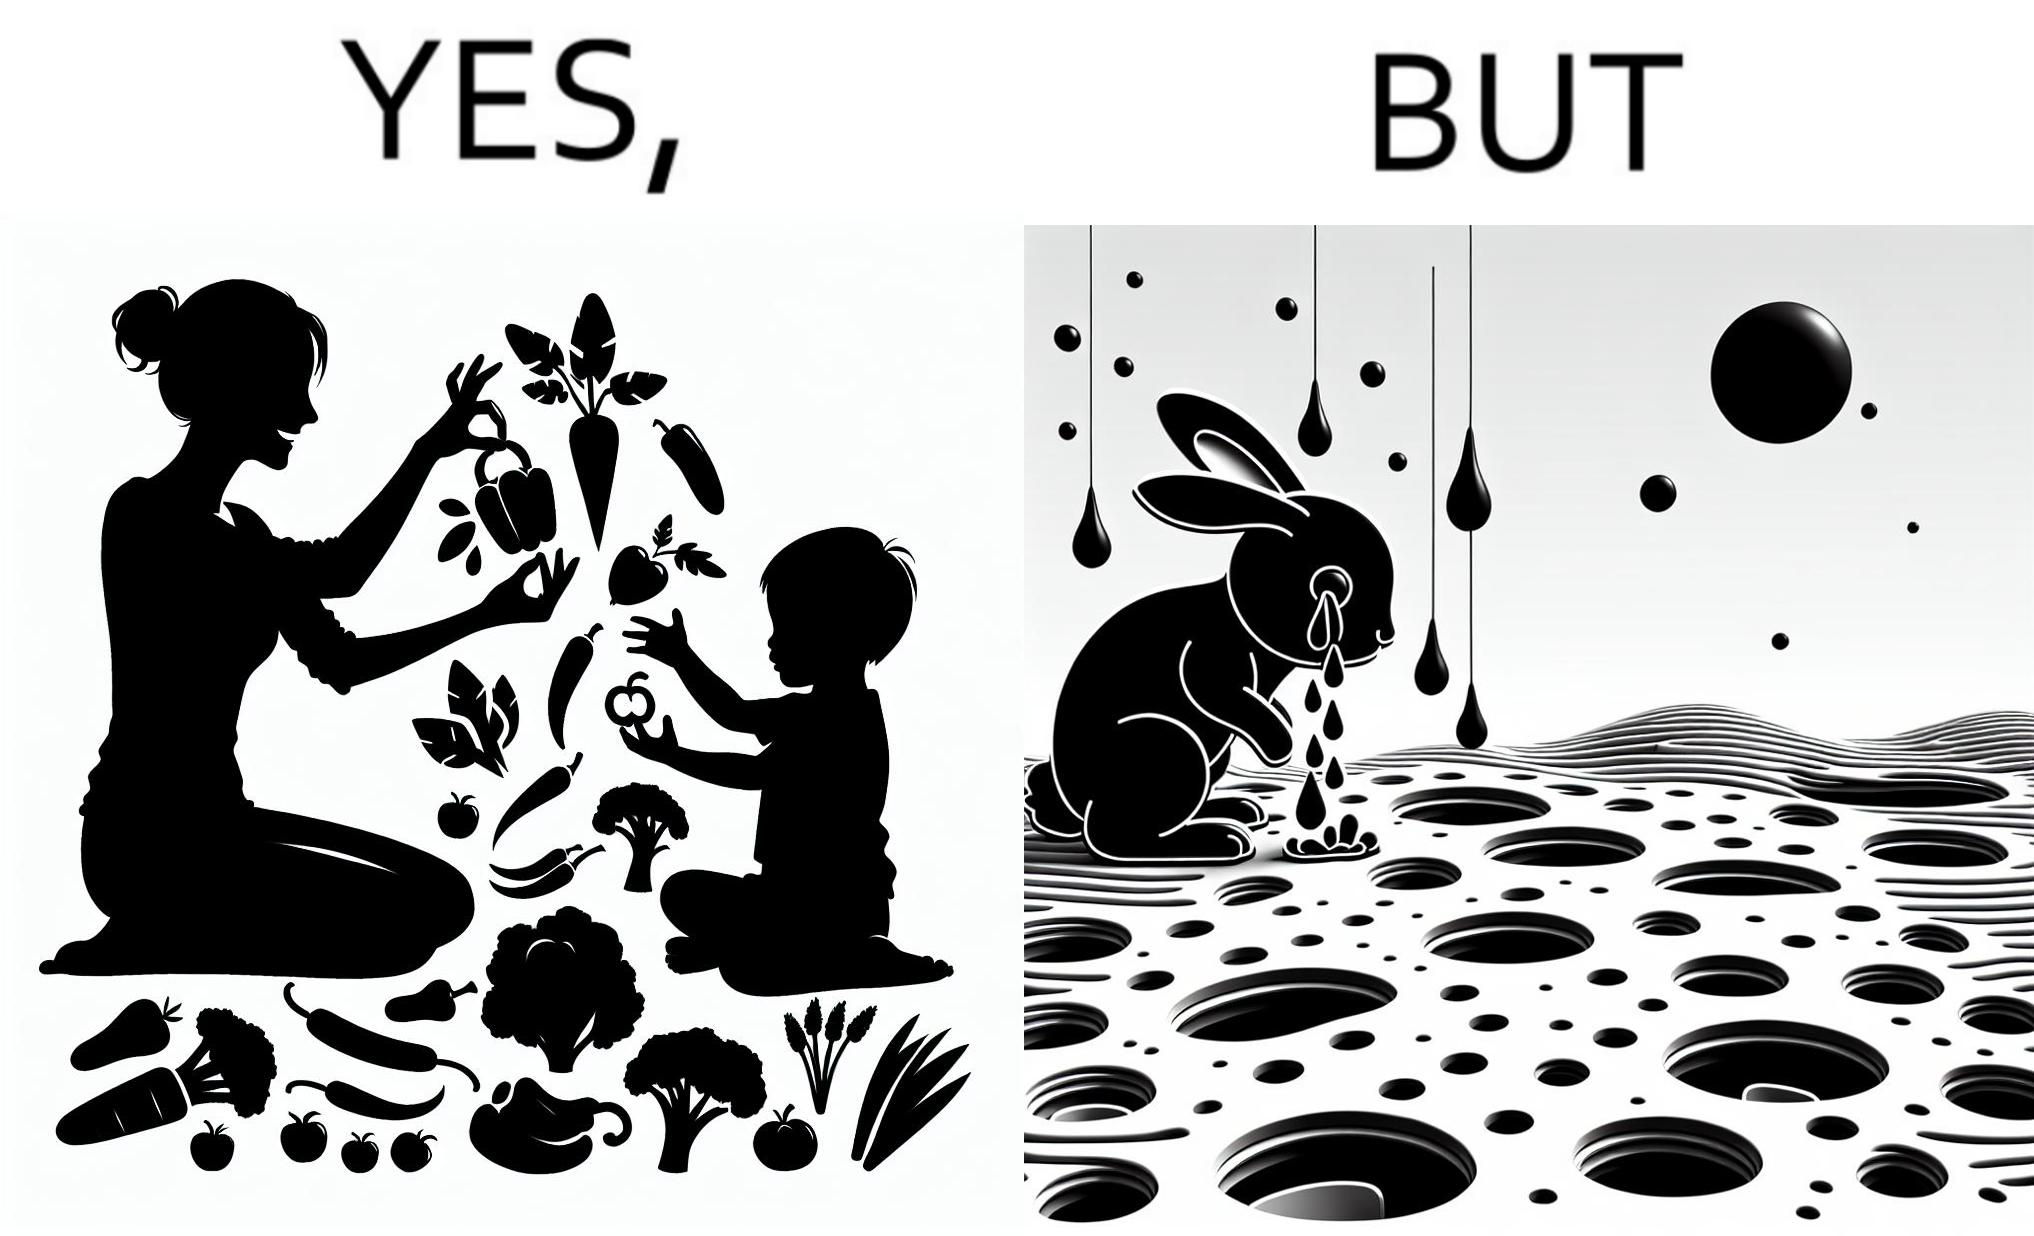Is this image satirical or non-satirical? Yes, this image is satirical. 